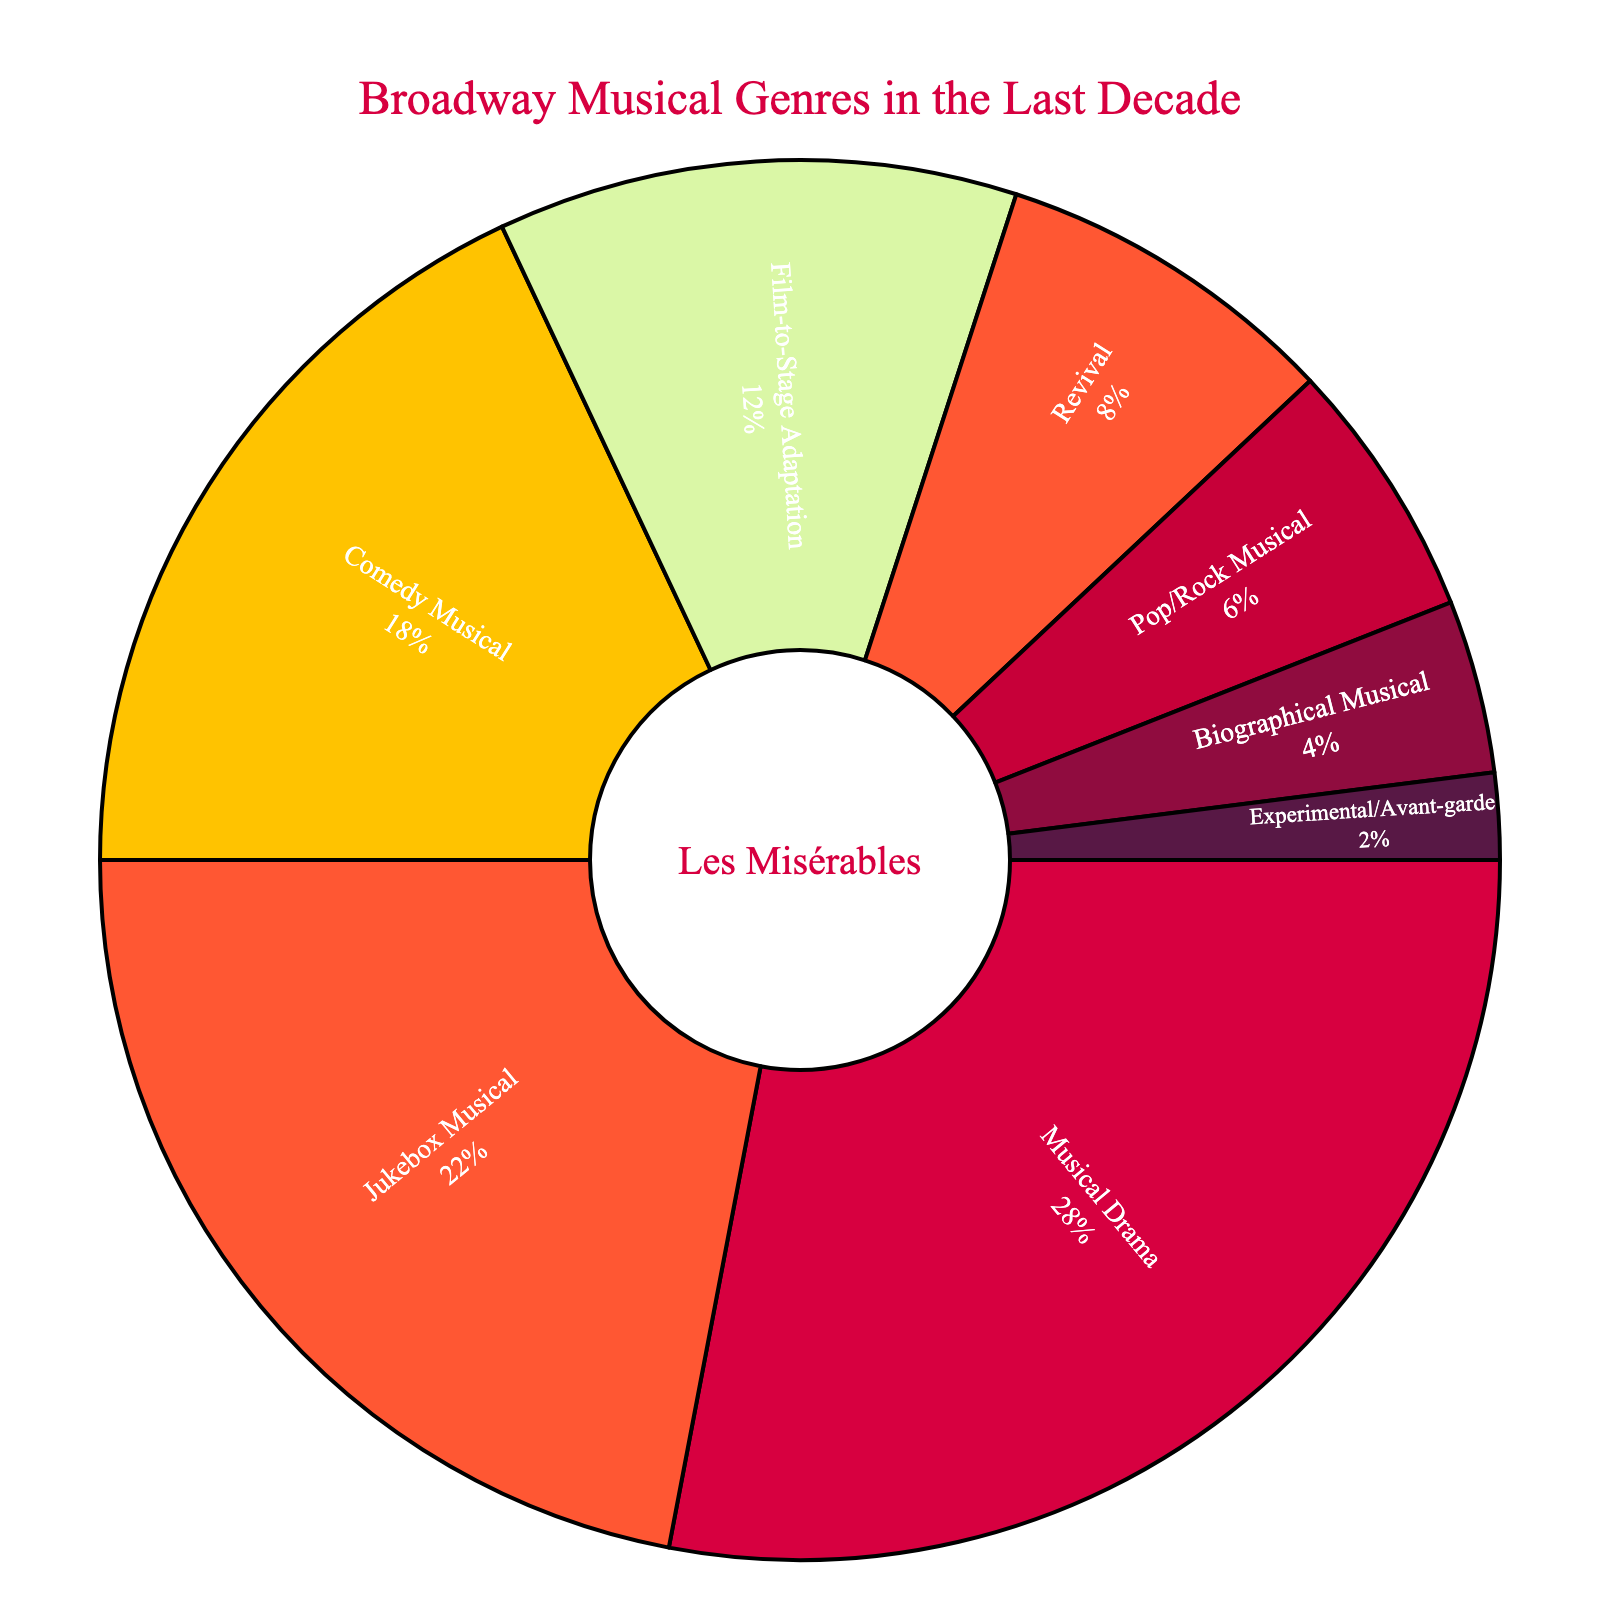What percentage of musicals were Biographical Musicals? Locate the section labeled "Biographical Musical" and check the percentage indicated. The figure shows it is 4%.
Answer: 4% How much greater is the percentage of Musical Dramas compared to Pop/Rock Musicals? Identify the percentage for both Musical Drama (28%) and Pop/Rock Musical (6%). Subtract the smaller percentage from the larger one: 28% - 6% = 22%.
Answer: 22% Which genre had the smallest representation? Identify the segment with the lowest percentage number. The Experimental/Avant-garde genre has the smallest percentage, which is 2%.
Answer: Experimental/Avant-garde What is the total percentage of comedy-related musicals (Comedy Musical + Jukebox Musical)? Sum the percentages of Comedy Musical (18%) and Jukebox Musical (22%): 18% + 22% = 40%.
Answer: 40% How does the percentage of Revivals compare to Film-to-Stage Adaptations? Compare the percentages: Revival (8%) and Film-to-Stage Adaptation (12%). Revivals have a lower percentage than Film-to-Stage Adaptations.
Answer: Revivals have a lower percentage What color represents the Revival segment in the pie chart? Identify the color segment associated with the label "Revival." The Revival segment uses the color orange.
Answer: Orange What's the combined percentage of the two least represented genres? Identify the two genres with the smallest percentages: Experimental/Avant-garde (2%) and Biographical Musical (4%). Sum them up: 2% + 4% = 6%.
Answer: 6% Which genre is represented by the largest segment? Identify the segment with the largest percentage. Musical Drama is the largest segment with 28%.
Answer: Musical Drama How much more popular are Jukebox Musicals compared to Biographical Musicals? Subtract the percentage of Biographical Musicals (4%) from Jukebox Musicals (22%): 22% - 4% = 18%.
Answer: 18% 